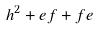Convert formula to latex. <formula><loc_0><loc_0><loc_500><loc_500>h ^ { 2 } + e f + f e</formula> 